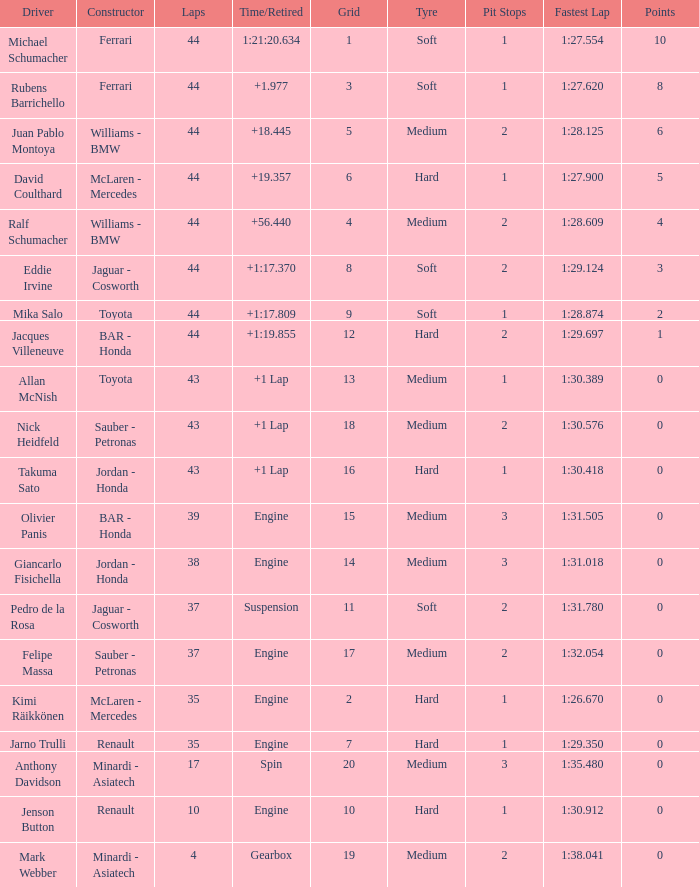What was the time of the driver on grid 3? 1.977. Can you give me this table as a dict? {'header': ['Driver', 'Constructor', 'Laps', 'Time/Retired', 'Grid', 'Tyre', 'Pit Stops', 'Fastest Lap', 'Points'], 'rows': [['Michael Schumacher', 'Ferrari', '44', '1:21:20.634', '1', 'Soft', '1', '1:27.554', '10'], ['Rubens Barrichello', 'Ferrari', '44', '+1.977', '3', 'Soft', '1', '1:27.620', '8'], ['Juan Pablo Montoya', 'Williams - BMW', '44', '+18.445', '5', 'Medium', '2', '1:28.125', '6'], ['David Coulthard', 'McLaren - Mercedes', '44', '+19.357', '6', 'Hard', '1', '1:27.900', '5'], ['Ralf Schumacher', 'Williams - BMW', '44', '+56.440', '4', 'Medium', '2', '1:28.609', '4'], ['Eddie Irvine', 'Jaguar - Cosworth', '44', '+1:17.370', '8', 'Soft', '2', '1:29.124', '3'], ['Mika Salo', 'Toyota', '44', '+1:17.809', '9', 'Soft', '1', '1:28.874', '2'], ['Jacques Villeneuve', 'BAR - Honda', '44', '+1:19.855', '12', 'Hard', '2', '1:29.697', '1'], ['Allan McNish', 'Toyota', '43', '+1 Lap', '13', 'Medium', '1', '1:30.389', '0'], ['Nick Heidfeld', 'Sauber - Petronas', '43', '+1 Lap', '18', 'Medium', '2', '1:30.576', '0'], ['Takuma Sato', 'Jordan - Honda', '43', '+1 Lap', '16', 'Hard', '1', '1:30.418', '0'], ['Olivier Panis', 'BAR - Honda', '39', 'Engine', '15', 'Medium', '3', '1:31.505', '0'], ['Giancarlo Fisichella', 'Jordan - Honda', '38', 'Engine', '14', 'Medium', '3', '1:31.018', '0'], ['Pedro de la Rosa', 'Jaguar - Cosworth', '37', 'Suspension', '11', 'Soft', '2', '1:31.780', '0'], ['Felipe Massa', 'Sauber - Petronas', '37', 'Engine', '17', 'Medium', '2', '1:32.054', '0'], ['Kimi Räikkönen', 'McLaren - Mercedes', '35', 'Engine', '2', 'Hard', '1', '1:26.670', '0'], ['Jarno Trulli', 'Renault', '35', 'Engine', '7', 'Hard', '1', '1:29.350', '0'], ['Anthony Davidson', 'Minardi - Asiatech', '17', 'Spin', '20', 'Medium', '3', '1:35.480', '0'], ['Jenson Button', 'Renault', '10', 'Engine', '10', 'Hard', '1', '1:30.912', '0'], ['Mark Webber', 'Minardi - Asiatech', '4', 'Gearbox', '19', 'Medium', '2', '1:38.041', '0']]} 